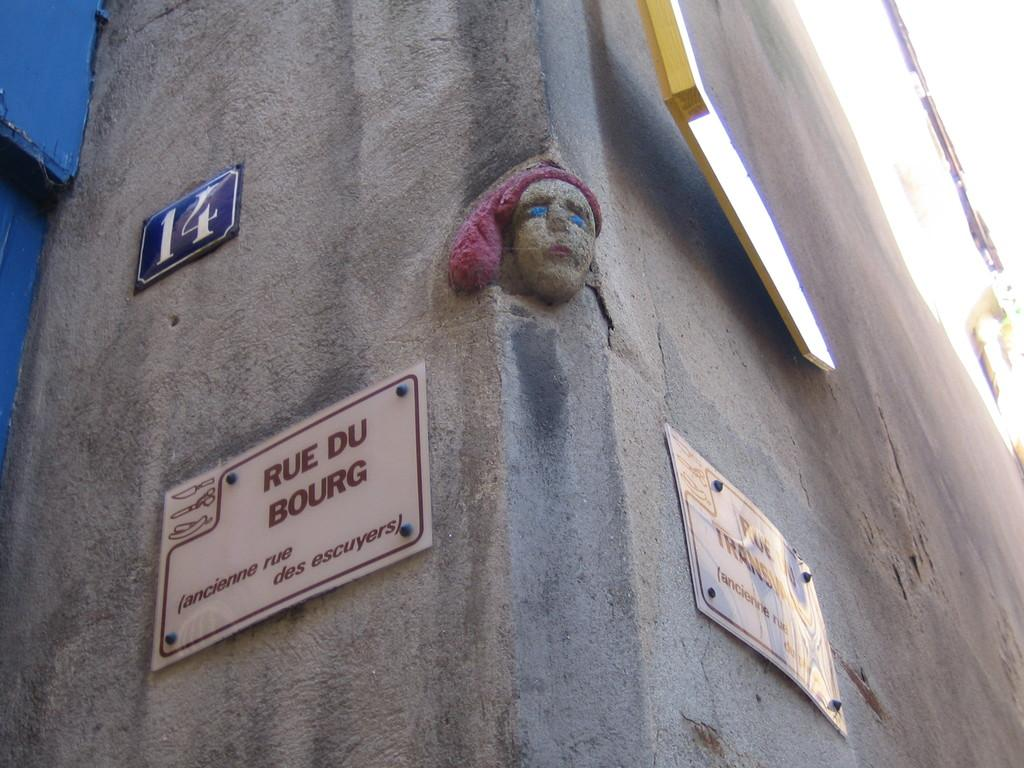What is present on the wall in the image? There is a wall in the image, and it has a carving of a woman's face. Are there any additional features on the wall? Yes, there are boards on the wall. What can be found on the boards? The boards have text and numbers on them. How many people are holding hands in the image? There is no crowd or people holding hands present in the image; it features a wall with a carving and boards. 